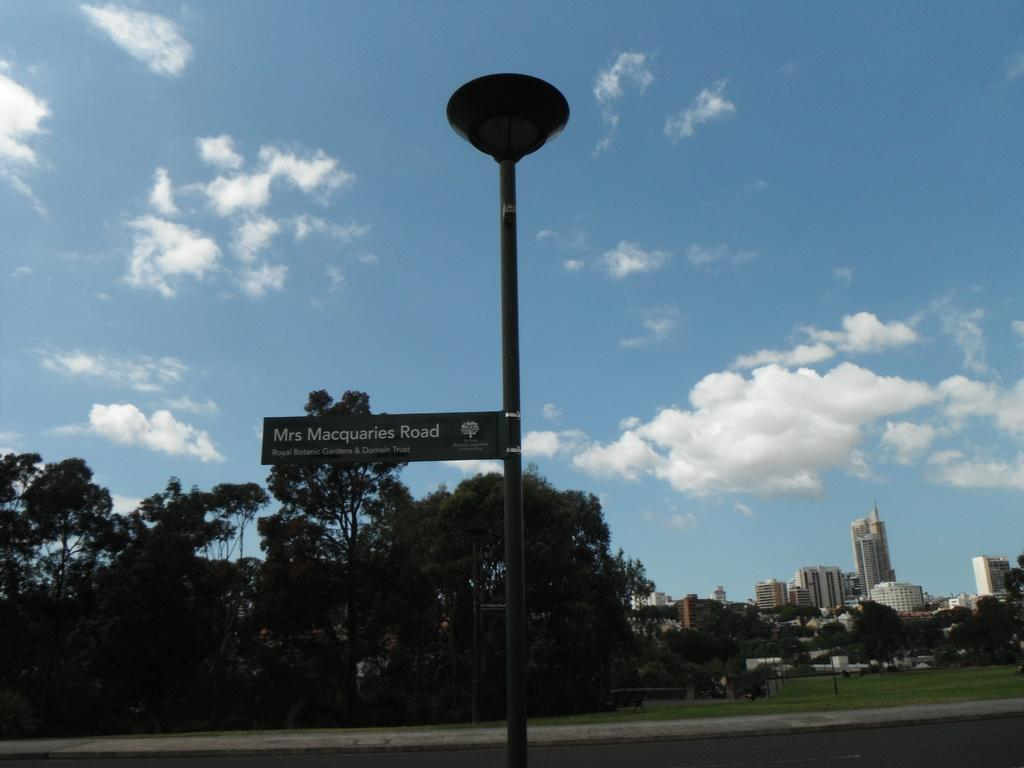What is attached to the light pole in the image? There is a name board attached to a light pole in the image. What type of vegetation can be seen in the image? There are trees in the image. What type of structures are visible in the image? There are buildings in the image. What can be seen in the background of the image? The sky is visible in the background of the image. What direction is the library facing in the image? There is no library present in the image, so it is not possible to determine the direction it might be facing. 